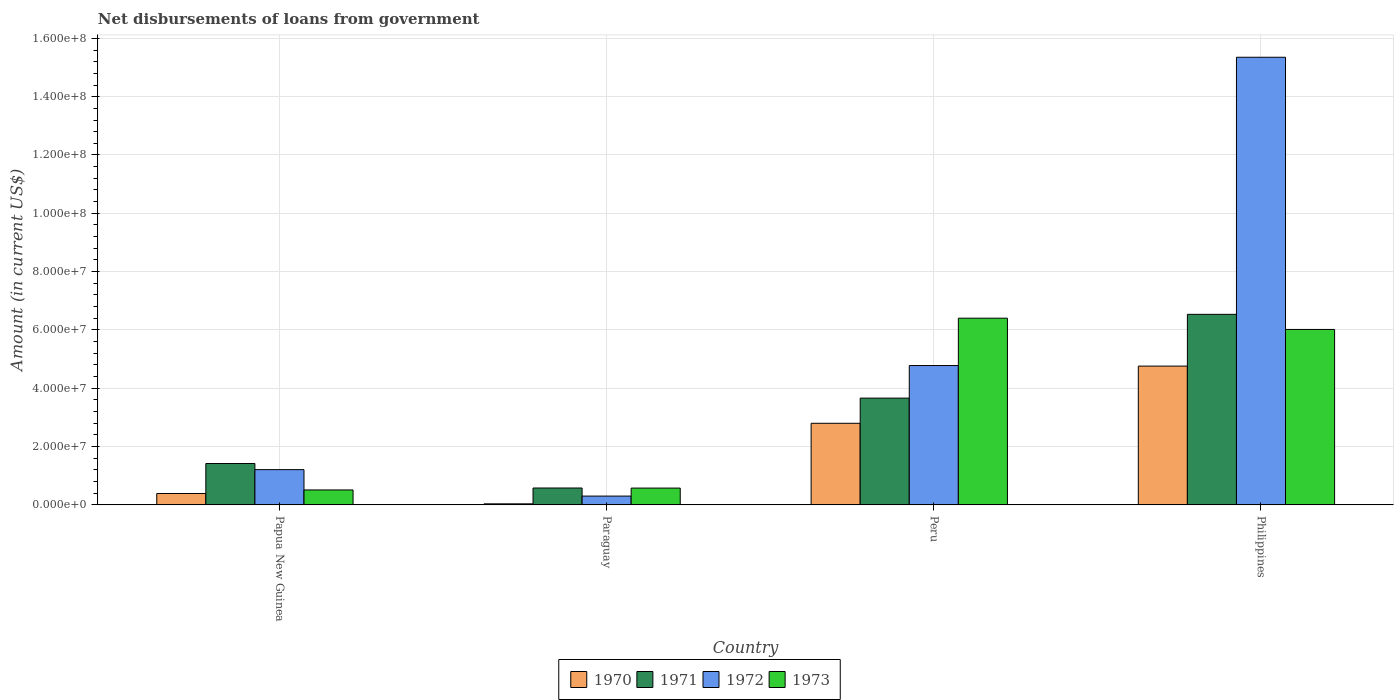How many different coloured bars are there?
Offer a very short reply. 4. How many groups of bars are there?
Your answer should be compact. 4. Are the number of bars on each tick of the X-axis equal?
Ensure brevity in your answer.  Yes. What is the label of the 2nd group of bars from the left?
Your answer should be compact. Paraguay. In how many cases, is the number of bars for a given country not equal to the number of legend labels?
Give a very brief answer. 0. What is the amount of loan disbursed from government in 1973 in Peru?
Provide a succinct answer. 6.40e+07. Across all countries, what is the maximum amount of loan disbursed from government in 1972?
Your answer should be very brief. 1.54e+08. Across all countries, what is the minimum amount of loan disbursed from government in 1971?
Your response must be concise. 5.80e+06. In which country was the amount of loan disbursed from government in 1971 maximum?
Provide a succinct answer. Philippines. In which country was the amount of loan disbursed from government in 1970 minimum?
Provide a succinct answer. Paraguay. What is the total amount of loan disbursed from government in 1972 in the graph?
Provide a succinct answer. 2.16e+08. What is the difference between the amount of loan disbursed from government in 1971 in Paraguay and that in Philippines?
Keep it short and to the point. -5.96e+07. What is the difference between the amount of loan disbursed from government in 1970 in Paraguay and the amount of loan disbursed from government in 1972 in Papua New Guinea?
Offer a very short reply. -1.17e+07. What is the average amount of loan disbursed from government in 1971 per country?
Your answer should be very brief. 3.05e+07. What is the difference between the amount of loan disbursed from government of/in 1972 and amount of loan disbursed from government of/in 1970 in Paraguay?
Provide a short and direct response. 2.66e+06. What is the ratio of the amount of loan disbursed from government in 1972 in Papua New Guinea to that in Philippines?
Make the answer very short. 0.08. Is the amount of loan disbursed from government in 1970 in Paraguay less than that in Philippines?
Your answer should be compact. Yes. What is the difference between the highest and the second highest amount of loan disbursed from government in 1971?
Provide a succinct answer. 2.87e+07. What is the difference between the highest and the lowest amount of loan disbursed from government in 1970?
Your response must be concise. 4.72e+07. What does the 2nd bar from the left in Philippines represents?
Give a very brief answer. 1971. What does the 3rd bar from the right in Papua New Guinea represents?
Offer a terse response. 1971. How many bars are there?
Offer a very short reply. 16. Are all the bars in the graph horizontal?
Your answer should be very brief. No. Are the values on the major ticks of Y-axis written in scientific E-notation?
Your response must be concise. Yes. Does the graph contain grids?
Offer a very short reply. Yes. How many legend labels are there?
Keep it short and to the point. 4. What is the title of the graph?
Your answer should be compact. Net disbursements of loans from government. Does "1967" appear as one of the legend labels in the graph?
Provide a succinct answer. No. What is the label or title of the Y-axis?
Ensure brevity in your answer.  Amount (in current US$). What is the Amount (in current US$) of 1970 in Papua New Guinea?
Give a very brief answer. 3.92e+06. What is the Amount (in current US$) in 1971 in Papua New Guinea?
Offer a terse response. 1.42e+07. What is the Amount (in current US$) in 1972 in Papua New Guinea?
Your response must be concise. 1.21e+07. What is the Amount (in current US$) in 1973 in Papua New Guinea?
Your answer should be very brief. 5.14e+06. What is the Amount (in current US$) in 1970 in Paraguay?
Offer a very short reply. 3.74e+05. What is the Amount (in current US$) of 1971 in Paraguay?
Provide a succinct answer. 5.80e+06. What is the Amount (in current US$) of 1972 in Paraguay?
Make the answer very short. 3.04e+06. What is the Amount (in current US$) of 1973 in Paraguay?
Your answer should be very brief. 5.78e+06. What is the Amount (in current US$) of 1970 in Peru?
Your answer should be very brief. 2.80e+07. What is the Amount (in current US$) of 1971 in Peru?
Your response must be concise. 3.66e+07. What is the Amount (in current US$) of 1972 in Peru?
Provide a succinct answer. 4.78e+07. What is the Amount (in current US$) in 1973 in Peru?
Your answer should be very brief. 6.40e+07. What is the Amount (in current US$) of 1970 in Philippines?
Give a very brief answer. 4.76e+07. What is the Amount (in current US$) of 1971 in Philippines?
Give a very brief answer. 6.54e+07. What is the Amount (in current US$) of 1972 in Philippines?
Provide a short and direct response. 1.54e+08. What is the Amount (in current US$) in 1973 in Philippines?
Provide a succinct answer. 6.02e+07. Across all countries, what is the maximum Amount (in current US$) in 1970?
Provide a succinct answer. 4.76e+07. Across all countries, what is the maximum Amount (in current US$) of 1971?
Give a very brief answer. 6.54e+07. Across all countries, what is the maximum Amount (in current US$) in 1972?
Ensure brevity in your answer.  1.54e+08. Across all countries, what is the maximum Amount (in current US$) of 1973?
Provide a succinct answer. 6.40e+07. Across all countries, what is the minimum Amount (in current US$) of 1970?
Offer a very short reply. 3.74e+05. Across all countries, what is the minimum Amount (in current US$) in 1971?
Keep it short and to the point. 5.80e+06. Across all countries, what is the minimum Amount (in current US$) of 1972?
Your answer should be very brief. 3.04e+06. Across all countries, what is the minimum Amount (in current US$) in 1973?
Keep it short and to the point. 5.14e+06. What is the total Amount (in current US$) of 1970 in the graph?
Your answer should be very brief. 7.99e+07. What is the total Amount (in current US$) in 1971 in the graph?
Offer a very short reply. 1.22e+08. What is the total Amount (in current US$) of 1972 in the graph?
Ensure brevity in your answer.  2.16e+08. What is the total Amount (in current US$) of 1973 in the graph?
Provide a succinct answer. 1.35e+08. What is the difference between the Amount (in current US$) in 1970 in Papua New Guinea and that in Paraguay?
Ensure brevity in your answer.  3.55e+06. What is the difference between the Amount (in current US$) of 1971 in Papua New Guinea and that in Paraguay?
Give a very brief answer. 8.40e+06. What is the difference between the Amount (in current US$) of 1972 in Papua New Guinea and that in Paraguay?
Keep it short and to the point. 9.07e+06. What is the difference between the Amount (in current US$) in 1973 in Papua New Guinea and that in Paraguay?
Offer a terse response. -6.38e+05. What is the difference between the Amount (in current US$) of 1970 in Papua New Guinea and that in Peru?
Provide a short and direct response. -2.41e+07. What is the difference between the Amount (in current US$) in 1971 in Papua New Guinea and that in Peru?
Give a very brief answer. -2.24e+07. What is the difference between the Amount (in current US$) of 1972 in Papua New Guinea and that in Peru?
Give a very brief answer. -3.57e+07. What is the difference between the Amount (in current US$) in 1973 in Papua New Guinea and that in Peru?
Provide a succinct answer. -5.89e+07. What is the difference between the Amount (in current US$) of 1970 in Papua New Guinea and that in Philippines?
Your answer should be compact. -4.37e+07. What is the difference between the Amount (in current US$) in 1971 in Papua New Guinea and that in Philippines?
Ensure brevity in your answer.  -5.12e+07. What is the difference between the Amount (in current US$) in 1972 in Papua New Guinea and that in Philippines?
Keep it short and to the point. -1.41e+08. What is the difference between the Amount (in current US$) in 1973 in Papua New Guinea and that in Philippines?
Your response must be concise. -5.50e+07. What is the difference between the Amount (in current US$) in 1970 in Paraguay and that in Peru?
Provide a short and direct response. -2.76e+07. What is the difference between the Amount (in current US$) in 1971 in Paraguay and that in Peru?
Provide a short and direct response. -3.08e+07. What is the difference between the Amount (in current US$) in 1972 in Paraguay and that in Peru?
Keep it short and to the point. -4.48e+07. What is the difference between the Amount (in current US$) in 1973 in Paraguay and that in Peru?
Your answer should be very brief. -5.83e+07. What is the difference between the Amount (in current US$) of 1970 in Paraguay and that in Philippines?
Your response must be concise. -4.72e+07. What is the difference between the Amount (in current US$) of 1971 in Paraguay and that in Philippines?
Make the answer very short. -5.96e+07. What is the difference between the Amount (in current US$) in 1972 in Paraguay and that in Philippines?
Offer a terse response. -1.50e+08. What is the difference between the Amount (in current US$) in 1973 in Paraguay and that in Philippines?
Ensure brevity in your answer.  -5.44e+07. What is the difference between the Amount (in current US$) in 1970 in Peru and that in Philippines?
Give a very brief answer. -1.96e+07. What is the difference between the Amount (in current US$) in 1971 in Peru and that in Philippines?
Your response must be concise. -2.87e+07. What is the difference between the Amount (in current US$) of 1972 in Peru and that in Philippines?
Keep it short and to the point. -1.06e+08. What is the difference between the Amount (in current US$) of 1973 in Peru and that in Philippines?
Ensure brevity in your answer.  3.86e+06. What is the difference between the Amount (in current US$) of 1970 in Papua New Guinea and the Amount (in current US$) of 1971 in Paraguay?
Provide a succinct answer. -1.88e+06. What is the difference between the Amount (in current US$) in 1970 in Papua New Guinea and the Amount (in current US$) in 1972 in Paraguay?
Offer a very short reply. 8.84e+05. What is the difference between the Amount (in current US$) in 1970 in Papua New Guinea and the Amount (in current US$) in 1973 in Paraguay?
Keep it short and to the point. -1.86e+06. What is the difference between the Amount (in current US$) of 1971 in Papua New Guinea and the Amount (in current US$) of 1972 in Paraguay?
Provide a succinct answer. 1.12e+07. What is the difference between the Amount (in current US$) in 1971 in Papua New Guinea and the Amount (in current US$) in 1973 in Paraguay?
Ensure brevity in your answer.  8.42e+06. What is the difference between the Amount (in current US$) of 1972 in Papua New Guinea and the Amount (in current US$) of 1973 in Paraguay?
Make the answer very short. 6.33e+06. What is the difference between the Amount (in current US$) of 1970 in Papua New Guinea and the Amount (in current US$) of 1971 in Peru?
Make the answer very short. -3.27e+07. What is the difference between the Amount (in current US$) in 1970 in Papua New Guinea and the Amount (in current US$) in 1972 in Peru?
Your answer should be compact. -4.39e+07. What is the difference between the Amount (in current US$) of 1970 in Papua New Guinea and the Amount (in current US$) of 1973 in Peru?
Make the answer very short. -6.01e+07. What is the difference between the Amount (in current US$) in 1971 in Papua New Guinea and the Amount (in current US$) in 1972 in Peru?
Offer a very short reply. -3.36e+07. What is the difference between the Amount (in current US$) in 1971 in Papua New Guinea and the Amount (in current US$) in 1973 in Peru?
Your answer should be compact. -4.98e+07. What is the difference between the Amount (in current US$) of 1972 in Papua New Guinea and the Amount (in current US$) of 1973 in Peru?
Your response must be concise. -5.19e+07. What is the difference between the Amount (in current US$) of 1970 in Papua New Guinea and the Amount (in current US$) of 1971 in Philippines?
Offer a terse response. -6.14e+07. What is the difference between the Amount (in current US$) of 1970 in Papua New Guinea and the Amount (in current US$) of 1972 in Philippines?
Your answer should be very brief. -1.50e+08. What is the difference between the Amount (in current US$) of 1970 in Papua New Guinea and the Amount (in current US$) of 1973 in Philippines?
Your answer should be very brief. -5.63e+07. What is the difference between the Amount (in current US$) of 1971 in Papua New Guinea and the Amount (in current US$) of 1972 in Philippines?
Offer a very short reply. -1.39e+08. What is the difference between the Amount (in current US$) of 1971 in Papua New Guinea and the Amount (in current US$) of 1973 in Philippines?
Provide a succinct answer. -4.60e+07. What is the difference between the Amount (in current US$) of 1972 in Papua New Guinea and the Amount (in current US$) of 1973 in Philippines?
Offer a terse response. -4.81e+07. What is the difference between the Amount (in current US$) of 1970 in Paraguay and the Amount (in current US$) of 1971 in Peru?
Provide a short and direct response. -3.63e+07. What is the difference between the Amount (in current US$) of 1970 in Paraguay and the Amount (in current US$) of 1972 in Peru?
Offer a very short reply. -4.74e+07. What is the difference between the Amount (in current US$) of 1970 in Paraguay and the Amount (in current US$) of 1973 in Peru?
Your answer should be very brief. -6.37e+07. What is the difference between the Amount (in current US$) in 1971 in Paraguay and the Amount (in current US$) in 1972 in Peru?
Provide a short and direct response. -4.20e+07. What is the difference between the Amount (in current US$) in 1971 in Paraguay and the Amount (in current US$) in 1973 in Peru?
Your response must be concise. -5.82e+07. What is the difference between the Amount (in current US$) of 1972 in Paraguay and the Amount (in current US$) of 1973 in Peru?
Your response must be concise. -6.10e+07. What is the difference between the Amount (in current US$) of 1970 in Paraguay and the Amount (in current US$) of 1971 in Philippines?
Offer a terse response. -6.50e+07. What is the difference between the Amount (in current US$) of 1970 in Paraguay and the Amount (in current US$) of 1972 in Philippines?
Provide a succinct answer. -1.53e+08. What is the difference between the Amount (in current US$) of 1970 in Paraguay and the Amount (in current US$) of 1973 in Philippines?
Offer a very short reply. -5.98e+07. What is the difference between the Amount (in current US$) in 1971 in Paraguay and the Amount (in current US$) in 1972 in Philippines?
Provide a short and direct response. -1.48e+08. What is the difference between the Amount (in current US$) of 1971 in Paraguay and the Amount (in current US$) of 1973 in Philippines?
Your response must be concise. -5.44e+07. What is the difference between the Amount (in current US$) in 1972 in Paraguay and the Amount (in current US$) in 1973 in Philippines?
Provide a succinct answer. -5.71e+07. What is the difference between the Amount (in current US$) in 1970 in Peru and the Amount (in current US$) in 1971 in Philippines?
Give a very brief answer. -3.74e+07. What is the difference between the Amount (in current US$) of 1970 in Peru and the Amount (in current US$) of 1972 in Philippines?
Ensure brevity in your answer.  -1.26e+08. What is the difference between the Amount (in current US$) of 1970 in Peru and the Amount (in current US$) of 1973 in Philippines?
Your answer should be compact. -3.22e+07. What is the difference between the Amount (in current US$) in 1971 in Peru and the Amount (in current US$) in 1972 in Philippines?
Provide a succinct answer. -1.17e+08. What is the difference between the Amount (in current US$) in 1971 in Peru and the Amount (in current US$) in 1973 in Philippines?
Your response must be concise. -2.36e+07. What is the difference between the Amount (in current US$) in 1972 in Peru and the Amount (in current US$) in 1973 in Philippines?
Provide a short and direct response. -1.24e+07. What is the average Amount (in current US$) in 1970 per country?
Give a very brief answer. 2.00e+07. What is the average Amount (in current US$) in 1971 per country?
Your response must be concise. 3.05e+07. What is the average Amount (in current US$) in 1972 per country?
Ensure brevity in your answer.  5.41e+07. What is the average Amount (in current US$) of 1973 per country?
Your response must be concise. 3.38e+07. What is the difference between the Amount (in current US$) in 1970 and Amount (in current US$) in 1971 in Papua New Guinea?
Provide a succinct answer. -1.03e+07. What is the difference between the Amount (in current US$) of 1970 and Amount (in current US$) of 1972 in Papua New Guinea?
Offer a terse response. -8.18e+06. What is the difference between the Amount (in current US$) of 1970 and Amount (in current US$) of 1973 in Papua New Guinea?
Your answer should be very brief. -1.22e+06. What is the difference between the Amount (in current US$) in 1971 and Amount (in current US$) in 1972 in Papua New Guinea?
Keep it short and to the point. 2.10e+06. What is the difference between the Amount (in current US$) in 1971 and Amount (in current US$) in 1973 in Papua New Guinea?
Your answer should be very brief. 9.06e+06. What is the difference between the Amount (in current US$) of 1972 and Amount (in current US$) of 1973 in Papua New Guinea?
Give a very brief answer. 6.96e+06. What is the difference between the Amount (in current US$) of 1970 and Amount (in current US$) of 1971 in Paraguay?
Offer a very short reply. -5.43e+06. What is the difference between the Amount (in current US$) in 1970 and Amount (in current US$) in 1972 in Paraguay?
Provide a succinct answer. -2.66e+06. What is the difference between the Amount (in current US$) of 1970 and Amount (in current US$) of 1973 in Paraguay?
Make the answer very short. -5.40e+06. What is the difference between the Amount (in current US$) of 1971 and Amount (in current US$) of 1972 in Paraguay?
Provide a short and direct response. 2.77e+06. What is the difference between the Amount (in current US$) in 1971 and Amount (in current US$) in 1973 in Paraguay?
Provide a succinct answer. 2.50e+04. What is the difference between the Amount (in current US$) in 1972 and Amount (in current US$) in 1973 in Paraguay?
Keep it short and to the point. -2.74e+06. What is the difference between the Amount (in current US$) of 1970 and Amount (in current US$) of 1971 in Peru?
Your answer should be very brief. -8.63e+06. What is the difference between the Amount (in current US$) of 1970 and Amount (in current US$) of 1972 in Peru?
Provide a succinct answer. -1.98e+07. What is the difference between the Amount (in current US$) of 1970 and Amount (in current US$) of 1973 in Peru?
Give a very brief answer. -3.60e+07. What is the difference between the Amount (in current US$) in 1971 and Amount (in current US$) in 1972 in Peru?
Give a very brief answer. -1.12e+07. What is the difference between the Amount (in current US$) in 1971 and Amount (in current US$) in 1973 in Peru?
Ensure brevity in your answer.  -2.74e+07. What is the difference between the Amount (in current US$) of 1972 and Amount (in current US$) of 1973 in Peru?
Provide a short and direct response. -1.62e+07. What is the difference between the Amount (in current US$) in 1970 and Amount (in current US$) in 1971 in Philippines?
Keep it short and to the point. -1.78e+07. What is the difference between the Amount (in current US$) in 1970 and Amount (in current US$) in 1972 in Philippines?
Provide a short and direct response. -1.06e+08. What is the difference between the Amount (in current US$) in 1970 and Amount (in current US$) in 1973 in Philippines?
Provide a short and direct response. -1.26e+07. What is the difference between the Amount (in current US$) of 1971 and Amount (in current US$) of 1972 in Philippines?
Offer a terse response. -8.82e+07. What is the difference between the Amount (in current US$) of 1971 and Amount (in current US$) of 1973 in Philippines?
Give a very brief answer. 5.18e+06. What is the difference between the Amount (in current US$) in 1972 and Amount (in current US$) in 1973 in Philippines?
Provide a short and direct response. 9.33e+07. What is the ratio of the Amount (in current US$) of 1970 in Papua New Guinea to that in Paraguay?
Offer a terse response. 10.48. What is the ratio of the Amount (in current US$) of 1971 in Papua New Guinea to that in Paraguay?
Your answer should be compact. 2.45. What is the ratio of the Amount (in current US$) in 1972 in Papua New Guinea to that in Paraguay?
Your answer should be compact. 3.99. What is the ratio of the Amount (in current US$) in 1973 in Papua New Guinea to that in Paraguay?
Provide a short and direct response. 0.89. What is the ratio of the Amount (in current US$) of 1970 in Papua New Guinea to that in Peru?
Keep it short and to the point. 0.14. What is the ratio of the Amount (in current US$) of 1971 in Papua New Guinea to that in Peru?
Provide a short and direct response. 0.39. What is the ratio of the Amount (in current US$) in 1972 in Papua New Guinea to that in Peru?
Offer a terse response. 0.25. What is the ratio of the Amount (in current US$) in 1973 in Papua New Guinea to that in Peru?
Make the answer very short. 0.08. What is the ratio of the Amount (in current US$) in 1970 in Papua New Guinea to that in Philippines?
Keep it short and to the point. 0.08. What is the ratio of the Amount (in current US$) in 1971 in Papua New Guinea to that in Philippines?
Provide a short and direct response. 0.22. What is the ratio of the Amount (in current US$) of 1972 in Papua New Guinea to that in Philippines?
Provide a short and direct response. 0.08. What is the ratio of the Amount (in current US$) of 1973 in Papua New Guinea to that in Philippines?
Make the answer very short. 0.09. What is the ratio of the Amount (in current US$) in 1970 in Paraguay to that in Peru?
Your answer should be very brief. 0.01. What is the ratio of the Amount (in current US$) in 1971 in Paraguay to that in Peru?
Give a very brief answer. 0.16. What is the ratio of the Amount (in current US$) of 1972 in Paraguay to that in Peru?
Your answer should be very brief. 0.06. What is the ratio of the Amount (in current US$) in 1973 in Paraguay to that in Peru?
Provide a succinct answer. 0.09. What is the ratio of the Amount (in current US$) of 1970 in Paraguay to that in Philippines?
Give a very brief answer. 0.01. What is the ratio of the Amount (in current US$) of 1971 in Paraguay to that in Philippines?
Ensure brevity in your answer.  0.09. What is the ratio of the Amount (in current US$) in 1972 in Paraguay to that in Philippines?
Keep it short and to the point. 0.02. What is the ratio of the Amount (in current US$) in 1973 in Paraguay to that in Philippines?
Make the answer very short. 0.1. What is the ratio of the Amount (in current US$) of 1970 in Peru to that in Philippines?
Keep it short and to the point. 0.59. What is the ratio of the Amount (in current US$) of 1971 in Peru to that in Philippines?
Provide a succinct answer. 0.56. What is the ratio of the Amount (in current US$) of 1972 in Peru to that in Philippines?
Offer a terse response. 0.31. What is the ratio of the Amount (in current US$) in 1973 in Peru to that in Philippines?
Make the answer very short. 1.06. What is the difference between the highest and the second highest Amount (in current US$) in 1970?
Offer a terse response. 1.96e+07. What is the difference between the highest and the second highest Amount (in current US$) in 1971?
Offer a very short reply. 2.87e+07. What is the difference between the highest and the second highest Amount (in current US$) in 1972?
Provide a succinct answer. 1.06e+08. What is the difference between the highest and the second highest Amount (in current US$) of 1973?
Your response must be concise. 3.86e+06. What is the difference between the highest and the lowest Amount (in current US$) of 1970?
Your answer should be very brief. 4.72e+07. What is the difference between the highest and the lowest Amount (in current US$) of 1971?
Make the answer very short. 5.96e+07. What is the difference between the highest and the lowest Amount (in current US$) in 1972?
Your response must be concise. 1.50e+08. What is the difference between the highest and the lowest Amount (in current US$) of 1973?
Give a very brief answer. 5.89e+07. 